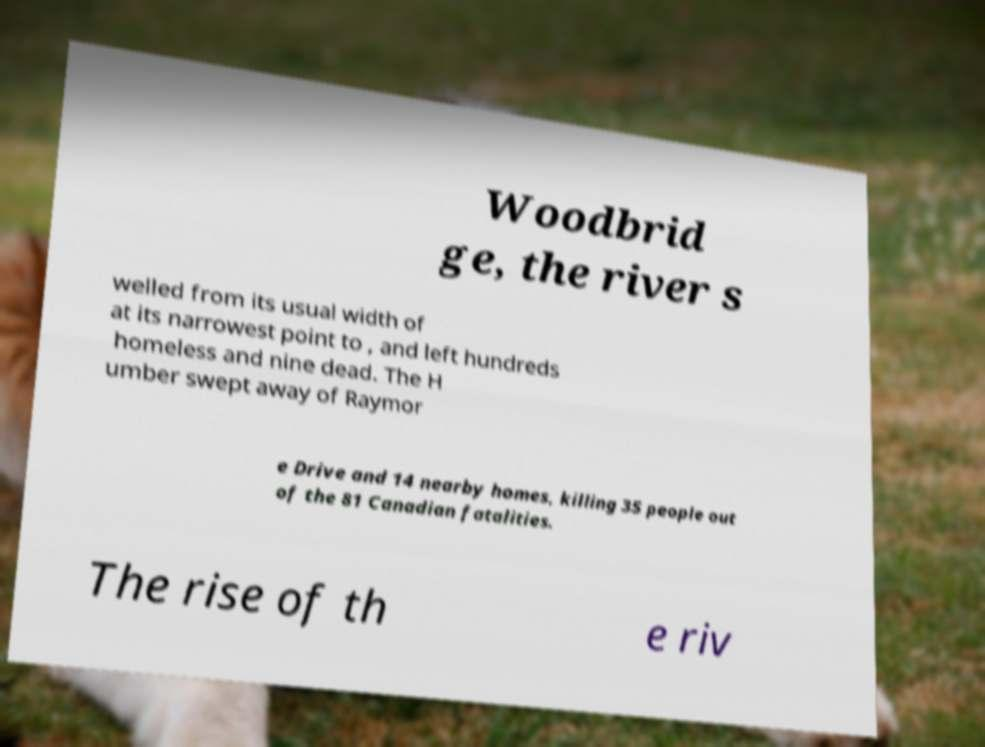I need the written content from this picture converted into text. Can you do that? Woodbrid ge, the river s welled from its usual width of at its narrowest point to , and left hundreds homeless and nine dead. The H umber swept away of Raymor e Drive and 14 nearby homes, killing 35 people out of the 81 Canadian fatalities. The rise of th e riv 